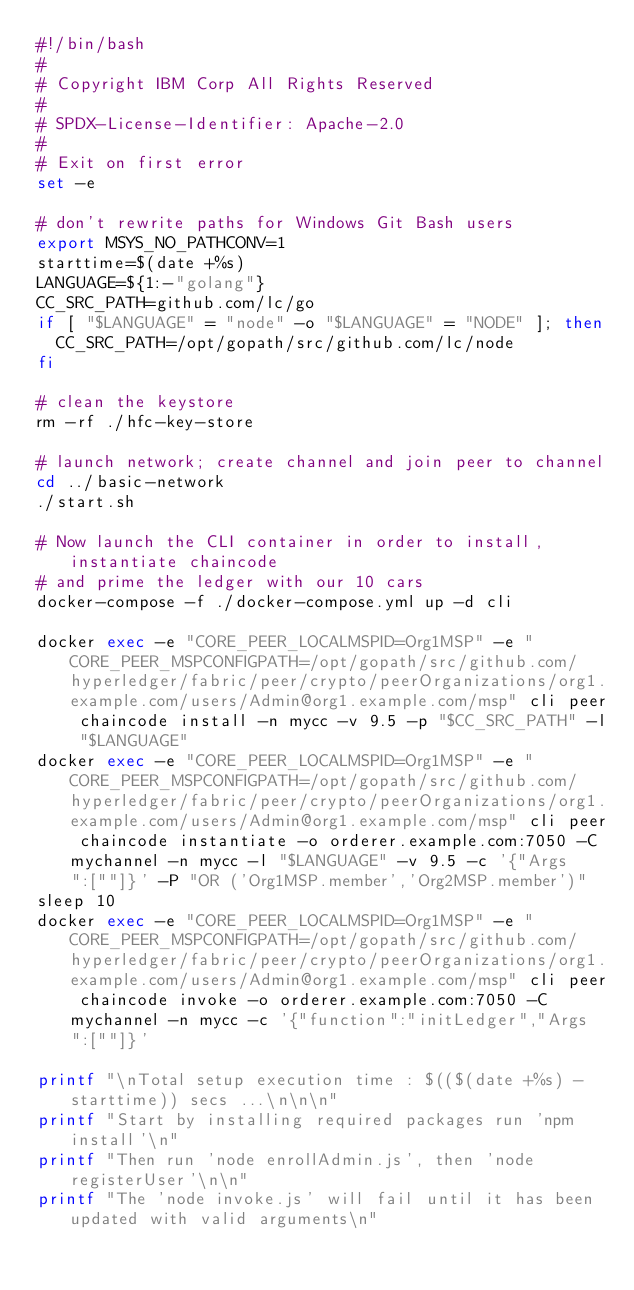<code> <loc_0><loc_0><loc_500><loc_500><_Bash_>#!/bin/bash
#
# Copyright IBM Corp All Rights Reserved
#
# SPDX-License-Identifier: Apache-2.0
#
# Exit on first error
set -e

# don't rewrite paths for Windows Git Bash users
export MSYS_NO_PATHCONV=1
starttime=$(date +%s)
LANGUAGE=${1:-"golang"}
CC_SRC_PATH=github.com/lc/go
if [ "$LANGUAGE" = "node" -o "$LANGUAGE" = "NODE" ]; then
	CC_SRC_PATH=/opt/gopath/src/github.com/lc/node
fi

# clean the keystore
rm -rf ./hfc-key-store

# launch network; create channel and join peer to channel
cd ../basic-network
./start.sh

# Now launch the CLI container in order to install, instantiate chaincode
# and prime the ledger with our 10 cars
docker-compose -f ./docker-compose.yml up -d cli

docker exec -e "CORE_PEER_LOCALMSPID=Org1MSP" -e "CORE_PEER_MSPCONFIGPATH=/opt/gopath/src/github.com/hyperledger/fabric/peer/crypto/peerOrganizations/org1.example.com/users/Admin@org1.example.com/msp" cli peer chaincode install -n mycc -v 9.5 -p "$CC_SRC_PATH" -l "$LANGUAGE"
docker exec -e "CORE_PEER_LOCALMSPID=Org1MSP" -e "CORE_PEER_MSPCONFIGPATH=/opt/gopath/src/github.com/hyperledger/fabric/peer/crypto/peerOrganizations/org1.example.com/users/Admin@org1.example.com/msp" cli peer chaincode instantiate -o orderer.example.com:7050 -C mychannel -n mycc -l "$LANGUAGE" -v 9.5 -c '{"Args":[""]}' -P "OR ('Org1MSP.member','Org2MSP.member')"
sleep 10
docker exec -e "CORE_PEER_LOCALMSPID=Org1MSP" -e "CORE_PEER_MSPCONFIGPATH=/opt/gopath/src/github.com/hyperledger/fabric/peer/crypto/peerOrganizations/org1.example.com/users/Admin@org1.example.com/msp" cli peer chaincode invoke -o orderer.example.com:7050 -C mychannel -n mycc -c '{"function":"initLedger","Args":[""]}'

printf "\nTotal setup execution time : $(($(date +%s) - starttime)) secs ...\n\n\n"
printf "Start by installing required packages run 'npm install'\n"
printf "Then run 'node enrollAdmin.js', then 'node registerUser'\n\n"
printf "The 'node invoke.js' will fail until it has been updated with valid arguments\n"</code> 